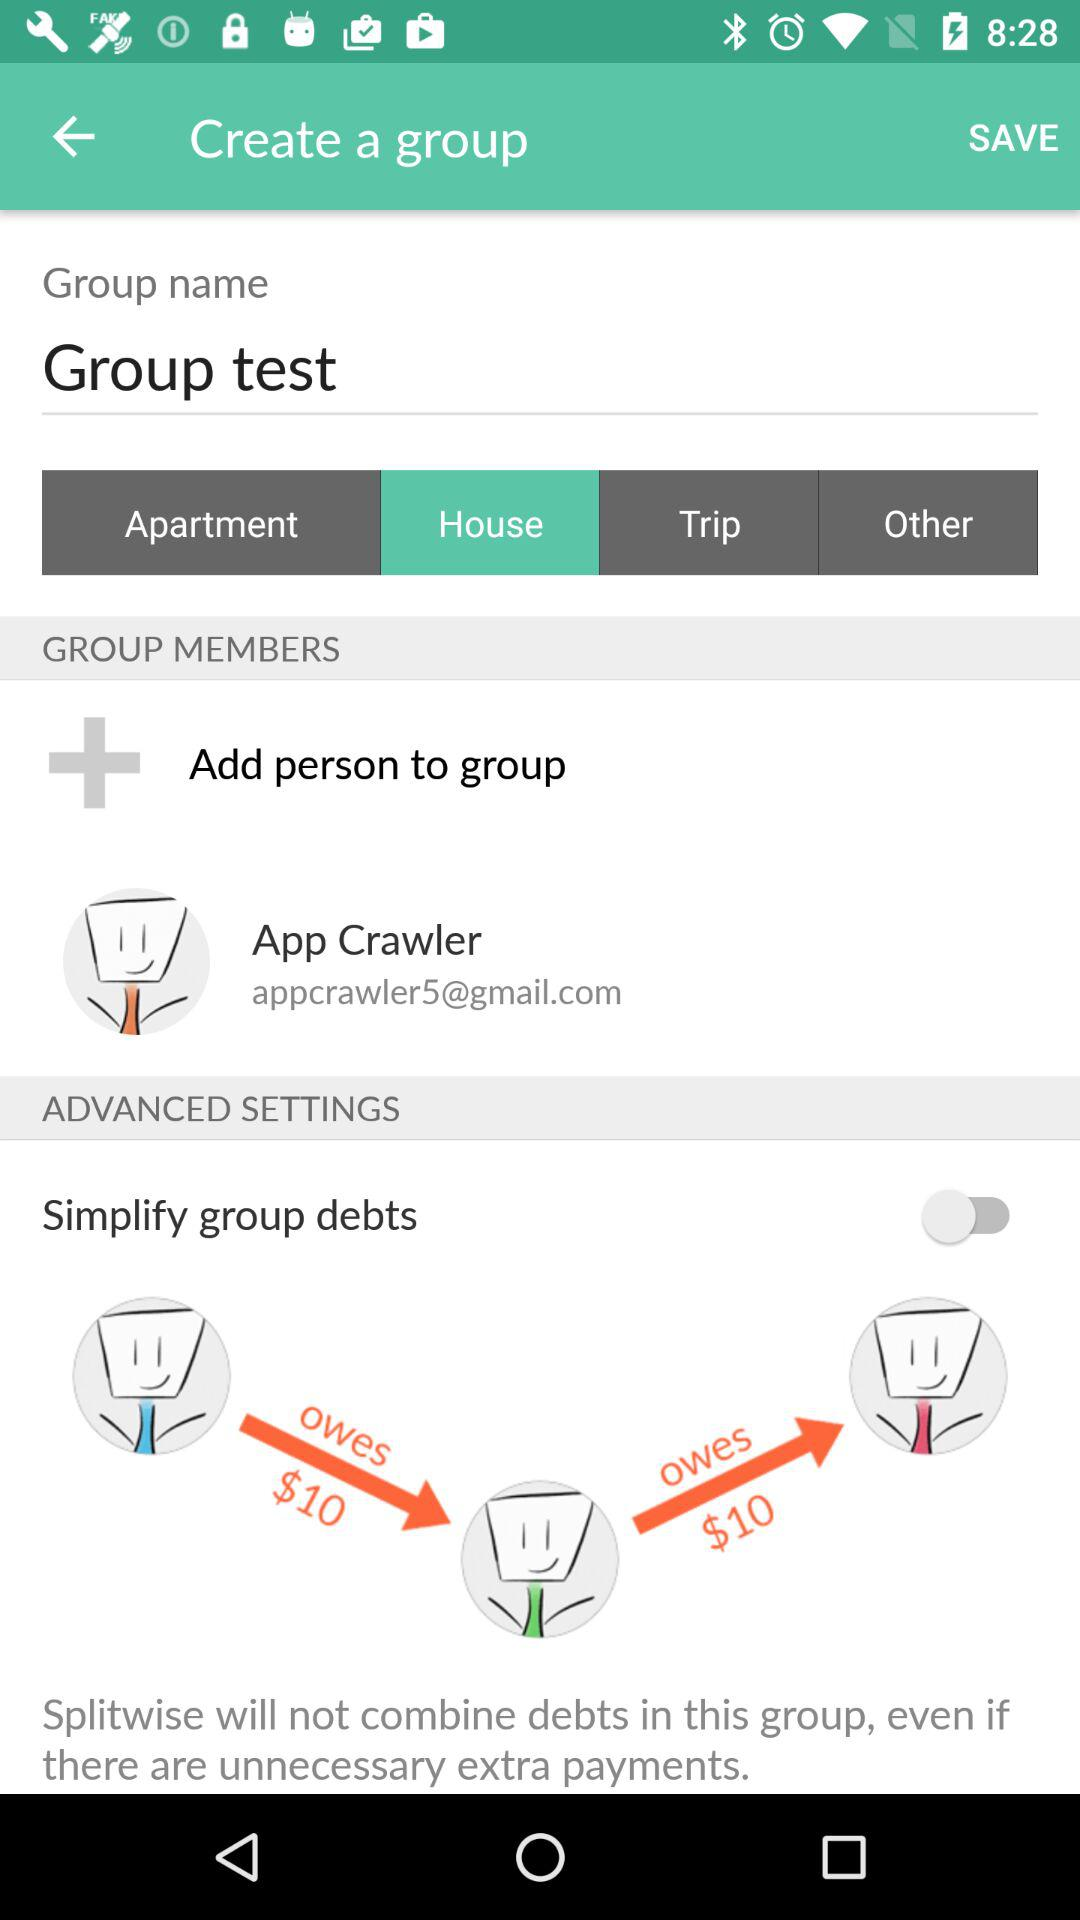Which tab has been selected? The selected tab is "House". 